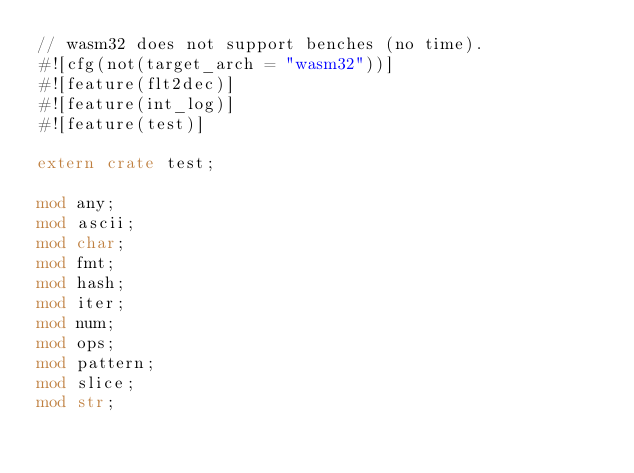Convert code to text. <code><loc_0><loc_0><loc_500><loc_500><_Rust_>// wasm32 does not support benches (no time).
#![cfg(not(target_arch = "wasm32"))]
#![feature(flt2dec)]
#![feature(int_log)]
#![feature(test)]

extern crate test;

mod any;
mod ascii;
mod char;
mod fmt;
mod hash;
mod iter;
mod num;
mod ops;
mod pattern;
mod slice;
mod str;
</code> 